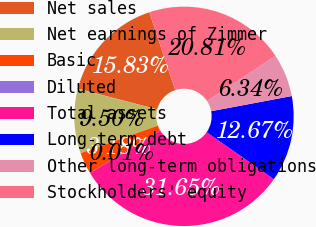Convert chart. <chart><loc_0><loc_0><loc_500><loc_500><pie_chart><fcel>Net sales<fcel>Net earnings of Zimmer<fcel>Basic<fcel>Diluted<fcel>Total assets<fcel>Long-term debt<fcel>Other long-term obligations<fcel>Stockholders' equity<nl><fcel>15.83%<fcel>9.5%<fcel>3.18%<fcel>0.01%<fcel>31.65%<fcel>12.67%<fcel>6.34%<fcel>20.81%<nl></chart> 